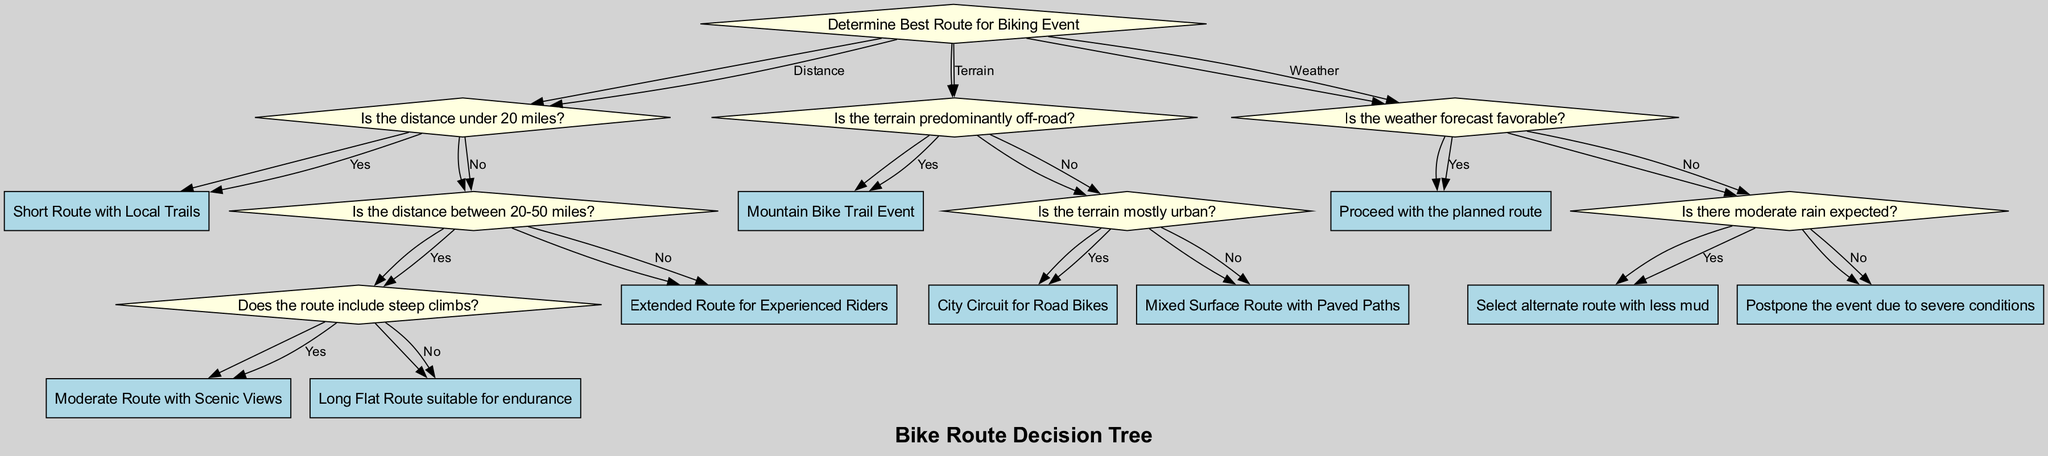What is the initial question at the root of the decision tree? The initial question determines what the diagram is guiding the user to consider regarding biking routes. It starts with "Determine Best Route for Biking Event."
Answer: Determine Best Route for Biking Event How many recommendations are there for routes based on distance? The decision tree outlines three distinct recommendations based on the distance options available (under 20 miles, between 20-50 miles with steep climbs or flat, and over 50 miles).
Answer: Three What recommendation is given if the distance is under 20 miles? When the distance is determined to be under 20 miles, the recommendation specified is to take a "Short Route with Local Trails."
Answer: Short Route with Local Trails What is the recommended route if the terrain is predominantly off-road? According to the terrain question, if the terrain is found to be predominantly off-road, the recommendation provided is to conduct a "Mountain Bike Trail Event."
Answer: Mountain Bike Trail Event What action should be taken if the weather forecast is unfavorable with severe conditions? If the weather is unfavorable and severe conditions are expected, the suggestion is to "Postpone the event due to severe conditions."
Answer: Postpone the event due to severe conditions What happens if the distance is greater than 50 miles? In the event that the distance exceeds 50 miles, the recommendation is to take an "Extended Route for Experienced Riders."
Answer: Extended Route for Experienced Riders What is the outcome if there is moderate rain expected? If moderate rain is anticipated, the decision from the tree indicates to "Select alternate route with less mud."
Answer: Select alternate route with less mud What is the recommendation for a route that is not primarily urban or off-road? For terrain that is not predominantly urban or off-road, the recommendation from the decision tree is to follow a "Mixed Surface Route with Paved Paths."
Answer: Mixed Surface Route with Paved Paths 